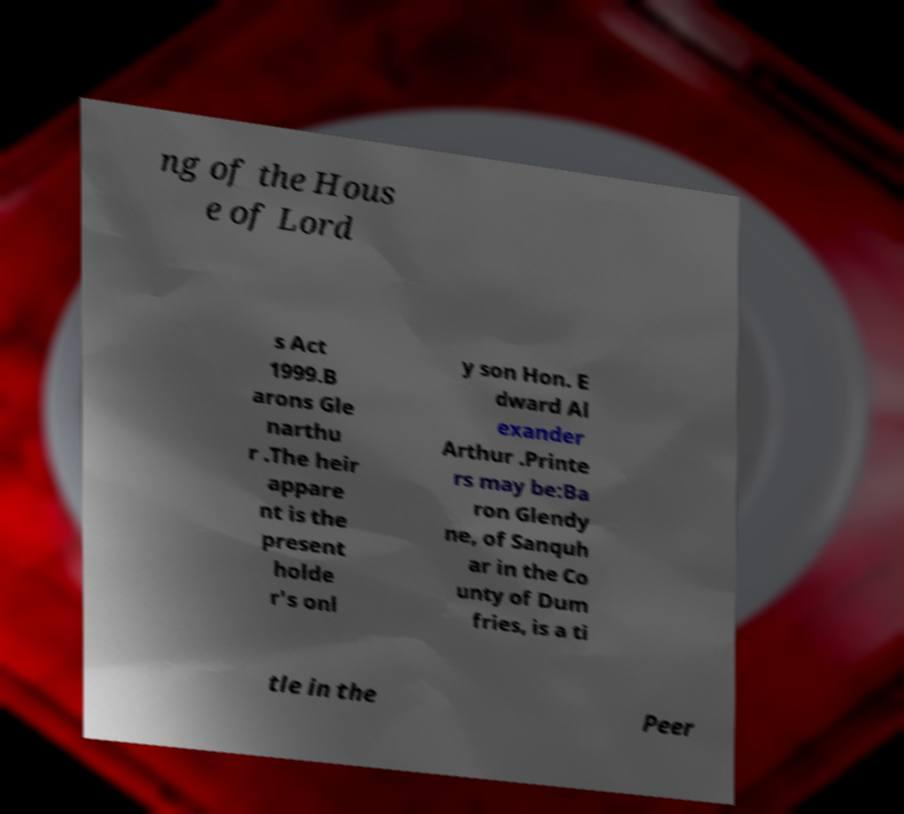What messages or text are displayed in this image? I need them in a readable, typed format. ng of the Hous e of Lord s Act 1999.B arons Gle narthu r .The heir appare nt is the present holde r's onl y son Hon. E dward Al exander Arthur .Printe rs may be:Ba ron Glendy ne, of Sanquh ar in the Co unty of Dum fries, is a ti tle in the Peer 